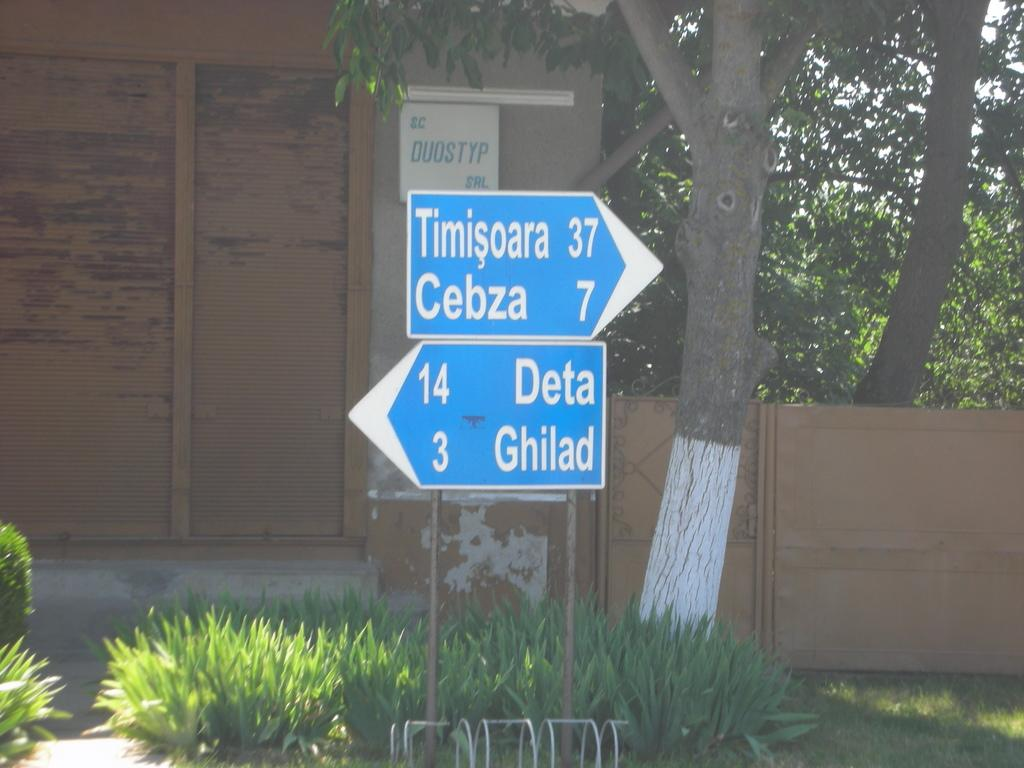What type of structure is present in the image? There is a building in the image. What type of natural vegetation is visible in the image? There are trees in the image. What is attached to the pole in the image? There is a pole with boards in the image. What type of ground surface is visible in the image? There is grass visible in the image. Where is the shop located in the image? There is no shop present in the image. What type of tank is visible in the image? There is no tank present in the image. How is the building connected to the pole in the image? The building is not connected to the pole in the image; they are separate structures. 